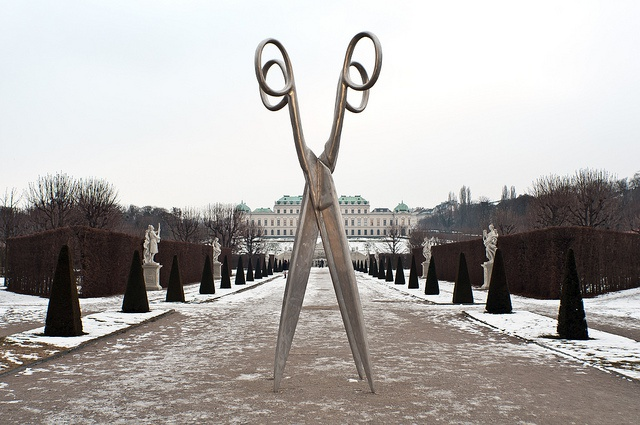Describe the objects in this image and their specific colors. I can see scissors in white, gray, and darkgray tones in this image. 